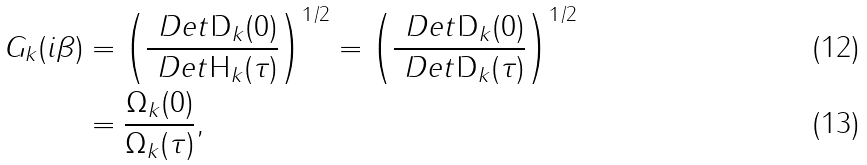<formula> <loc_0><loc_0><loc_500><loc_500>G _ { k } ( i \beta ) & = \left ( \frac { \ D e t \mathsf D _ { k } ( 0 ) } { \ D e t \mathsf H _ { k } ( \tau ) } \right ) ^ { 1 / 2 } = \left ( \frac { \ D e t \mathsf D _ { k } ( 0 ) } { \ D e t \mathsf D _ { k } ( \tau ) } \right ) ^ { 1 / 2 } \\ & = \frac { \Omega _ { k } ( 0 ) } { \Omega _ { k } ( \tau ) } ,</formula> 